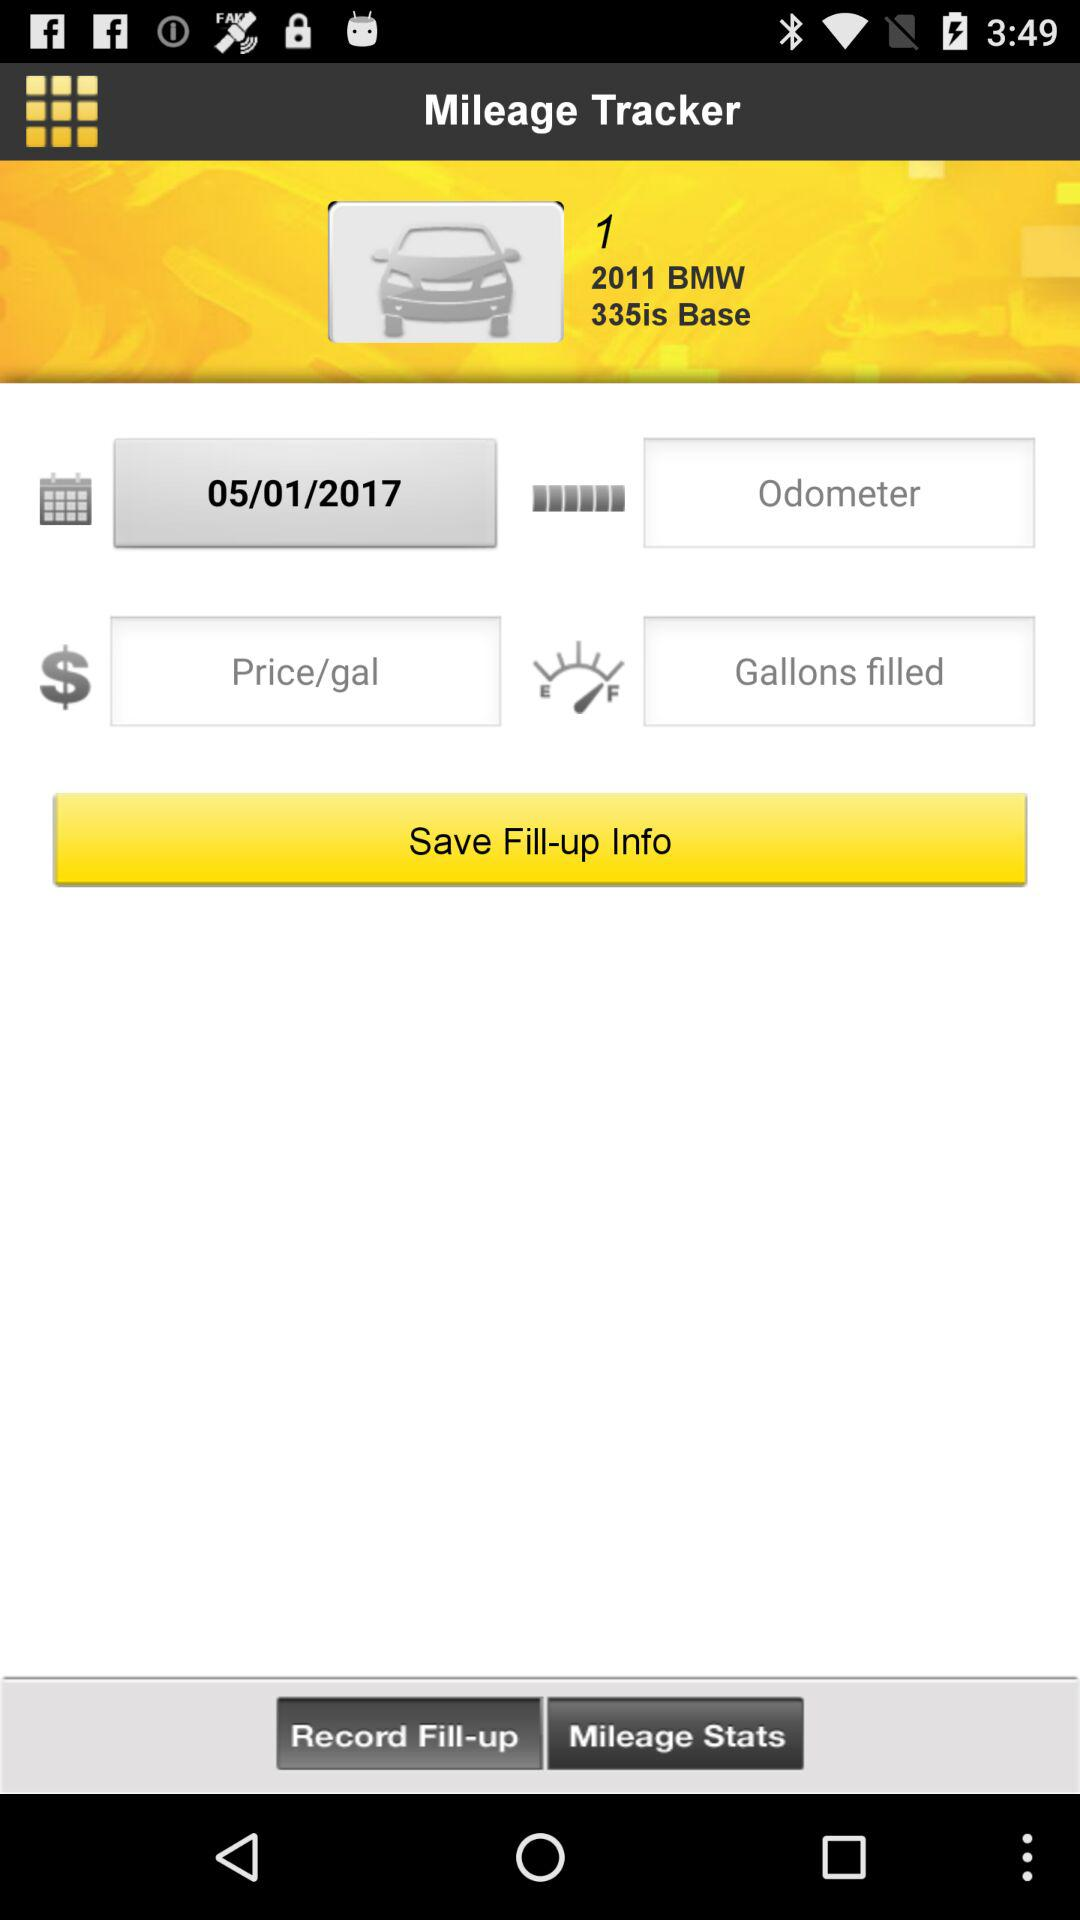What is the given date? The given date is 05/01/2017. 